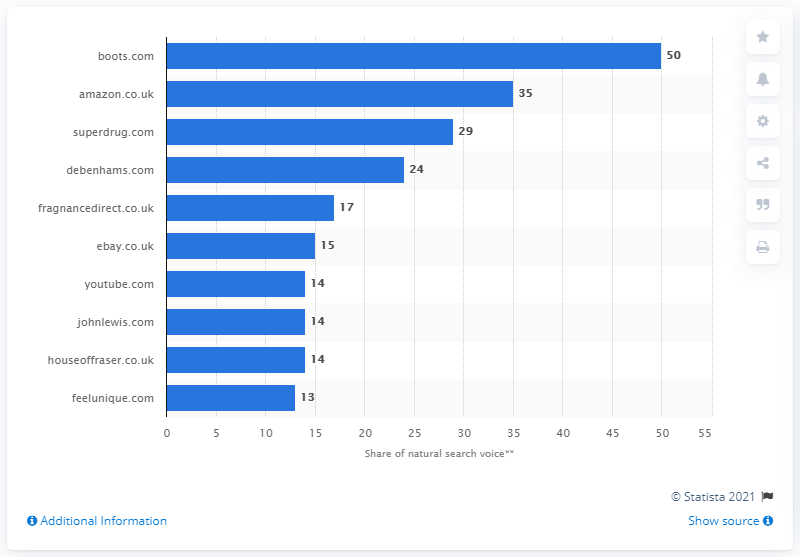Highlight a few significant elements in this photo. According to a recent study, Boots.com was the website that received the highest share of natural search voice, with a 50% share. 